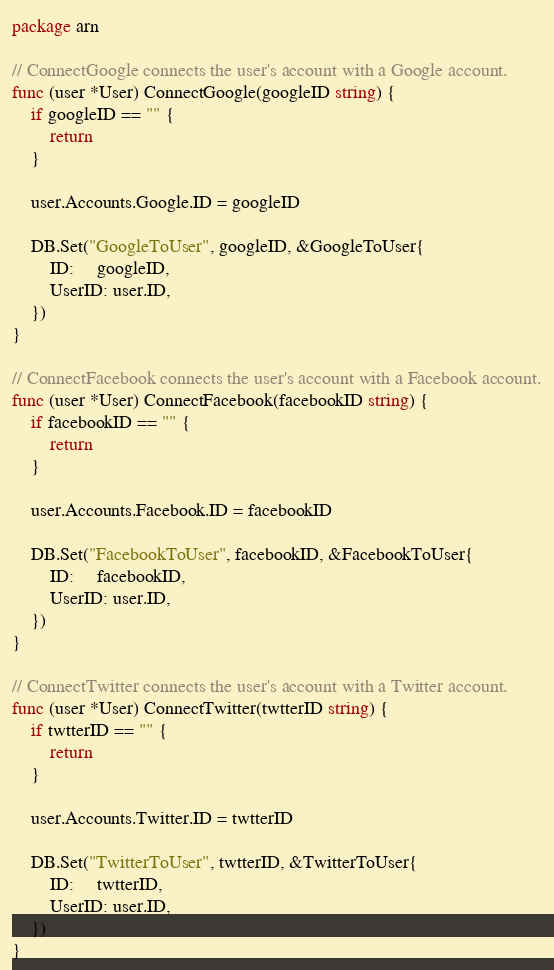Convert code to text. <code><loc_0><loc_0><loc_500><loc_500><_Go_>package arn

// ConnectGoogle connects the user's account with a Google account.
func (user *User) ConnectGoogle(googleID string) {
	if googleID == "" {
		return
	}

	user.Accounts.Google.ID = googleID

	DB.Set("GoogleToUser", googleID, &GoogleToUser{
		ID:     googleID,
		UserID: user.ID,
	})
}

// ConnectFacebook connects the user's account with a Facebook account.
func (user *User) ConnectFacebook(facebookID string) {
	if facebookID == "" {
		return
	}

	user.Accounts.Facebook.ID = facebookID

	DB.Set("FacebookToUser", facebookID, &FacebookToUser{
		ID:     facebookID,
		UserID: user.ID,
	})
}

// ConnectTwitter connects the user's account with a Twitter account.
func (user *User) ConnectTwitter(twtterID string) {
	if twtterID == "" {
		return
	}

	user.Accounts.Twitter.ID = twtterID

	DB.Set("TwitterToUser", twtterID, &TwitterToUser{
		ID:     twtterID,
		UserID: user.ID,
	})
}
</code> 